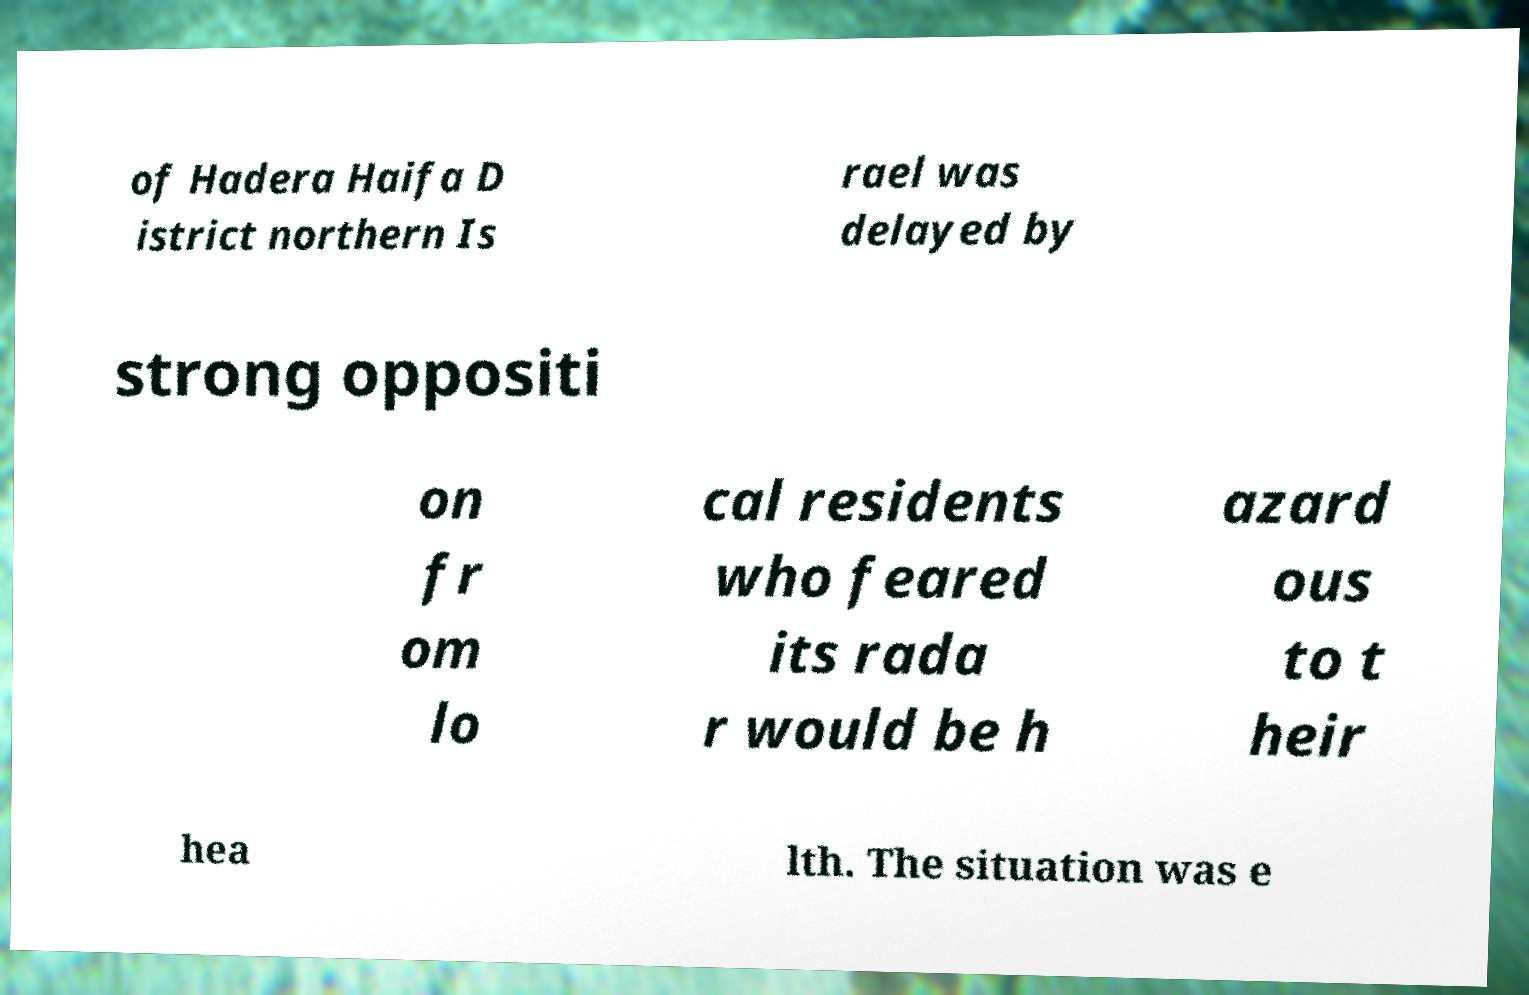Please identify and transcribe the text found in this image. of Hadera Haifa D istrict northern Is rael was delayed by strong oppositi on fr om lo cal residents who feared its rada r would be h azard ous to t heir hea lth. The situation was e 